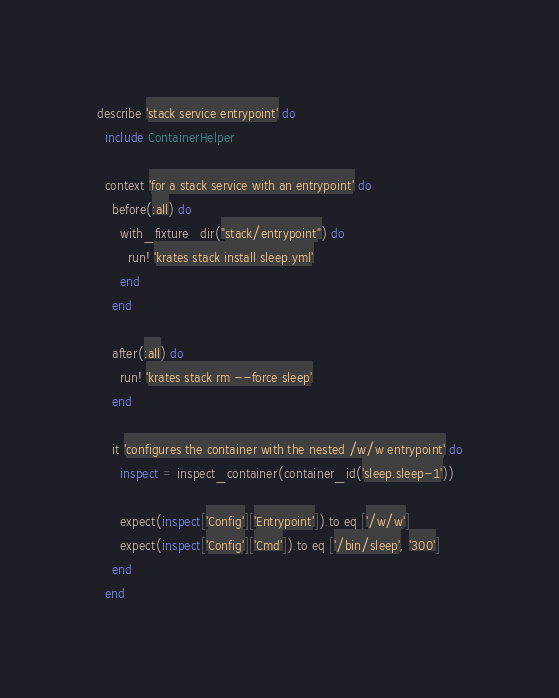<code> <loc_0><loc_0><loc_500><loc_500><_Ruby_>describe 'stack service entrypoint' do
  include ContainerHelper

  context 'for a stack service with an entrypoint' do
    before(:all) do
      with_fixture_dir("stack/entrypoint") do
        run! 'krates stack install sleep.yml'
      end
    end

    after(:all) do
      run! 'krates stack rm --force sleep'
    end

    it 'configures the container with the nested /w/w entrypoint' do
      inspect = inspect_container(container_id('sleep.sleep-1'))

      expect(inspect['Config']['Entrypoint']).to eq ['/w/w']
      expect(inspect['Config']['Cmd']).to eq ['/bin/sleep', '300']
    end
  end
</code> 